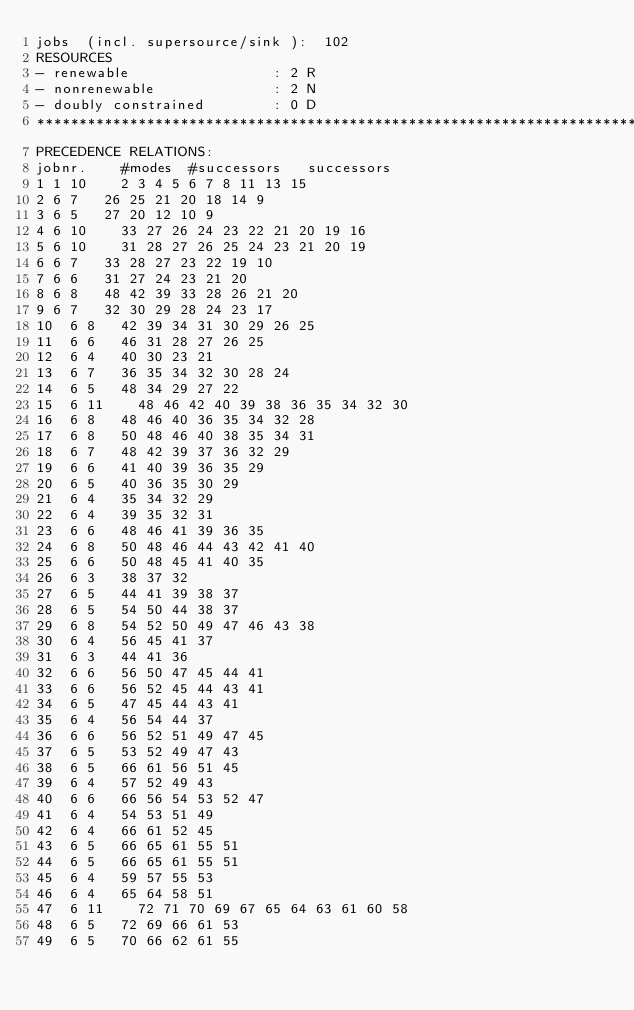<code> <loc_0><loc_0><loc_500><loc_500><_ObjectiveC_>jobs  (incl. supersource/sink ):	102
RESOURCES
- renewable                 : 2 R
- nonrenewable              : 2 N
- doubly constrained        : 0 D
************************************************************************
PRECEDENCE RELATIONS:
jobnr.    #modes  #successors   successors
1	1	10		2 3 4 5 6 7 8 11 13 15 
2	6	7		26 25 21 20 18 14 9 
3	6	5		27 20 12 10 9 
4	6	10		33 27 26 24 23 22 21 20 19 16 
5	6	10		31 28 27 26 25 24 23 21 20 19 
6	6	7		33 28 27 23 22 19 10 
7	6	6		31 27 24 23 21 20 
8	6	8		48 42 39 33 28 26 21 20 
9	6	7		32 30 29 28 24 23 17 
10	6	8		42 39 34 31 30 29 26 25 
11	6	6		46 31 28 27 26 25 
12	6	4		40 30 23 21 
13	6	7		36 35 34 32 30 28 24 
14	6	5		48 34 29 27 22 
15	6	11		48 46 42 40 39 38 36 35 34 32 30 
16	6	8		48 46 40 36 35 34 32 28 
17	6	8		50 48 46 40 38 35 34 31 
18	6	7		48 42 39 37 36 32 29 
19	6	6		41 40 39 36 35 29 
20	6	5		40 36 35 30 29 
21	6	4		35 34 32 29 
22	6	4		39 35 32 31 
23	6	6		48 46 41 39 36 35 
24	6	8		50 48 46 44 43 42 41 40 
25	6	6		50 48 45 41 40 35 
26	6	3		38 37 32 
27	6	5		44 41 39 38 37 
28	6	5		54 50 44 38 37 
29	6	8		54 52 50 49 47 46 43 38 
30	6	4		56 45 41 37 
31	6	3		44 41 36 
32	6	6		56 50 47 45 44 41 
33	6	6		56 52 45 44 43 41 
34	6	5		47 45 44 43 41 
35	6	4		56 54 44 37 
36	6	6		56 52 51 49 47 45 
37	6	5		53 52 49 47 43 
38	6	5		66 61 56 51 45 
39	6	4		57 52 49 43 
40	6	6		66 56 54 53 52 47 
41	6	4		54 53 51 49 
42	6	4		66 61 52 45 
43	6	5		66 65 61 55 51 
44	6	5		66 65 61 55 51 
45	6	4		59 57 55 53 
46	6	4		65 64 58 51 
47	6	11		72 71 70 69 67 65 64 63 61 60 58 
48	6	5		72 69 66 61 53 
49	6	5		70 66 62 61 55 </code> 